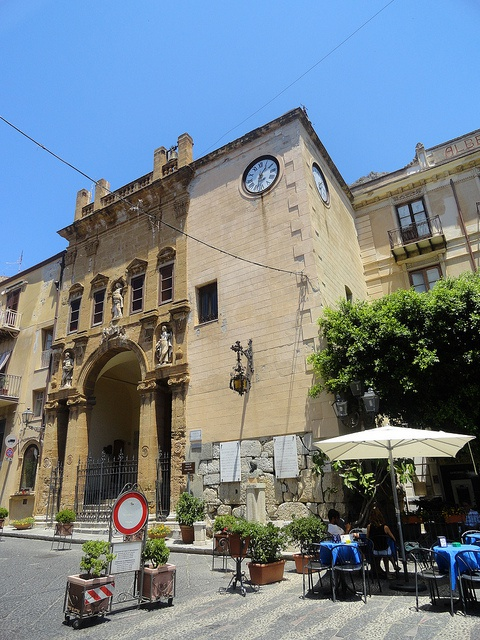Describe the objects in this image and their specific colors. I can see umbrella in lightblue, beige, white, darkgray, and tan tones, potted plant in lightblue, black, gray, darkgray, and darkgreen tones, potted plant in lightblue, black, olive, maroon, and gray tones, potted plant in lightblue, gray, black, and darkgreen tones, and potted plant in lightblue, black, darkgreen, gray, and olive tones in this image. 